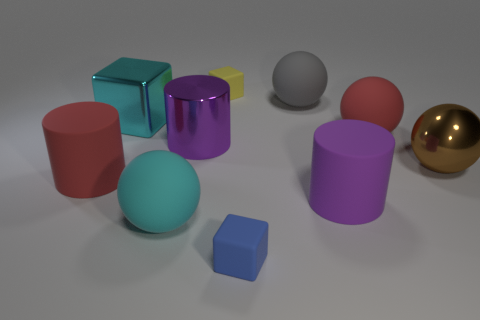Subtract all big cyan blocks. How many blocks are left? 2 Subtract all blue balls. How many purple cylinders are left? 2 Subtract 1 spheres. How many spheres are left? 3 Subtract all cyan spheres. How many spheres are left? 3 Subtract all cubes. How many objects are left? 7 Subtract all brown cylinders. Subtract all purple blocks. How many cylinders are left? 3 Subtract all tiny red matte cubes. Subtract all large brown metallic objects. How many objects are left? 9 Add 7 brown objects. How many brown objects are left? 8 Add 1 large cyan spheres. How many large cyan spheres exist? 2 Subtract 0 yellow spheres. How many objects are left? 10 